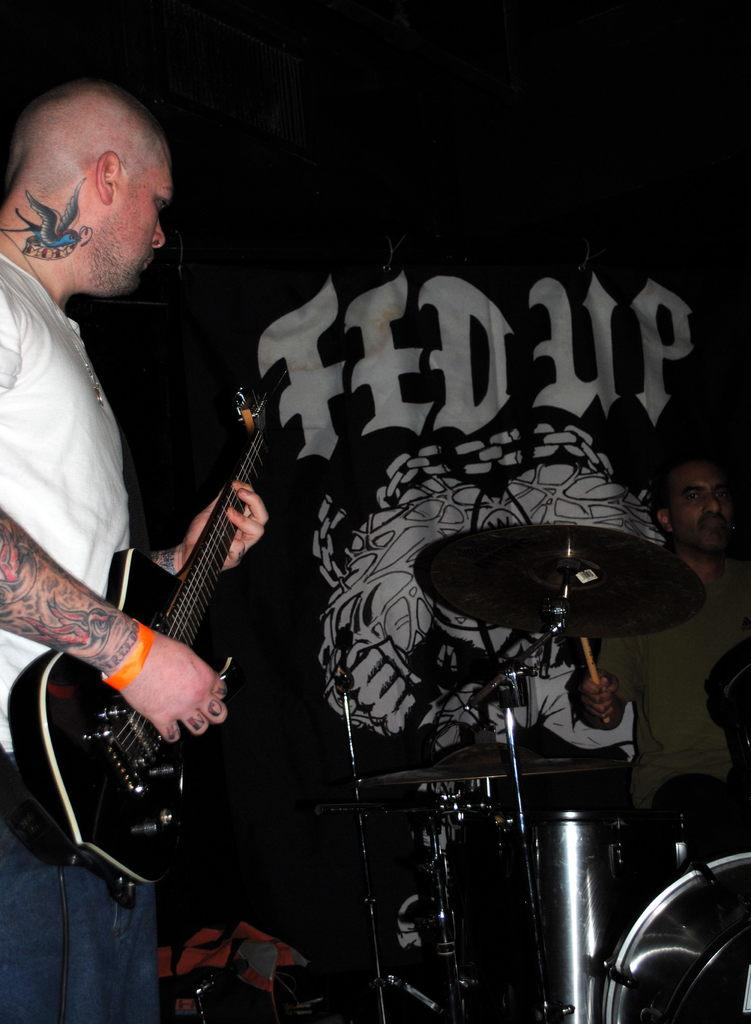What is the man in the image doing? The man is playing a guitar in the image. What is the man wearing while playing the guitar? The man is wearing a white t-shirt. How is the man positioned while playing the guitar? The man is sitting while playing the guitar. What is the man using to play the guitar? The man is using a stick to play the guitar. What type of breakfast is the man eating in the image? There is no breakfast present in the image; the man is playing a guitar. 